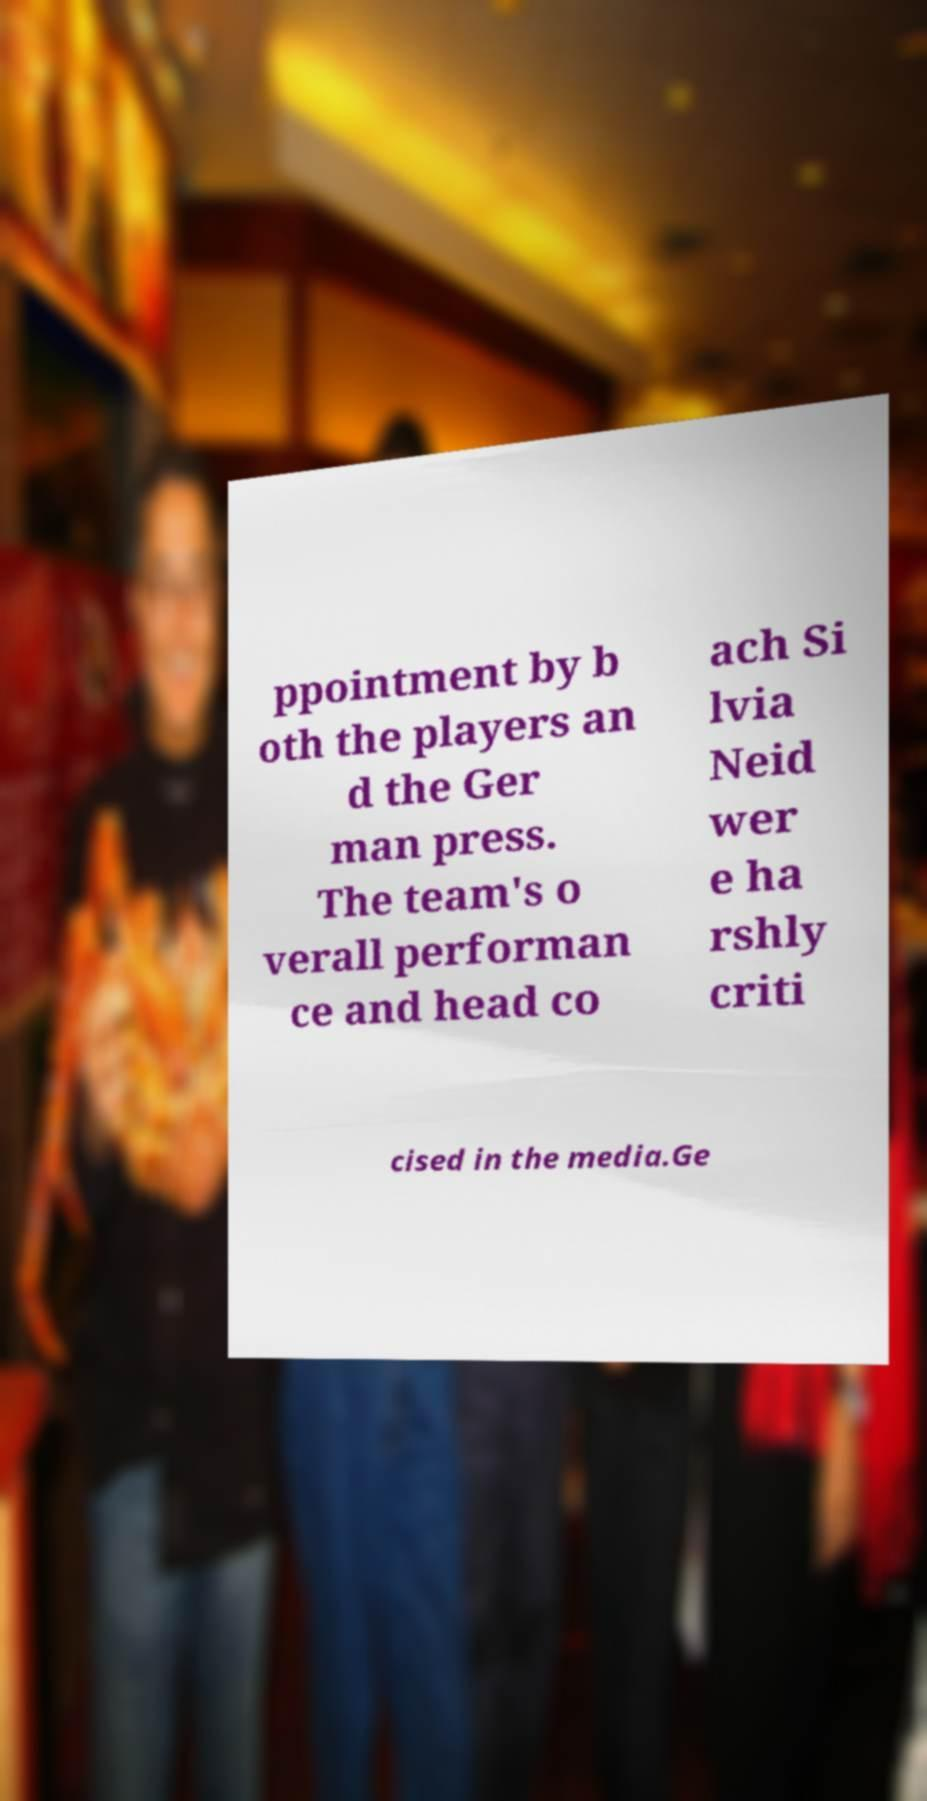I need the written content from this picture converted into text. Can you do that? ppointment by b oth the players an d the Ger man press. The team's o verall performan ce and head co ach Si lvia Neid wer e ha rshly criti cised in the media.Ge 